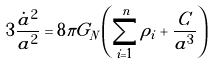Convert formula to latex. <formula><loc_0><loc_0><loc_500><loc_500>3 \frac { \dot { a } ^ { 2 } } { a ^ { 2 } } = 8 \pi G _ { N } \left ( \sum _ { i = 1 } ^ { n } \rho _ { i } + \frac { C } { a ^ { 3 } } \right )</formula> 